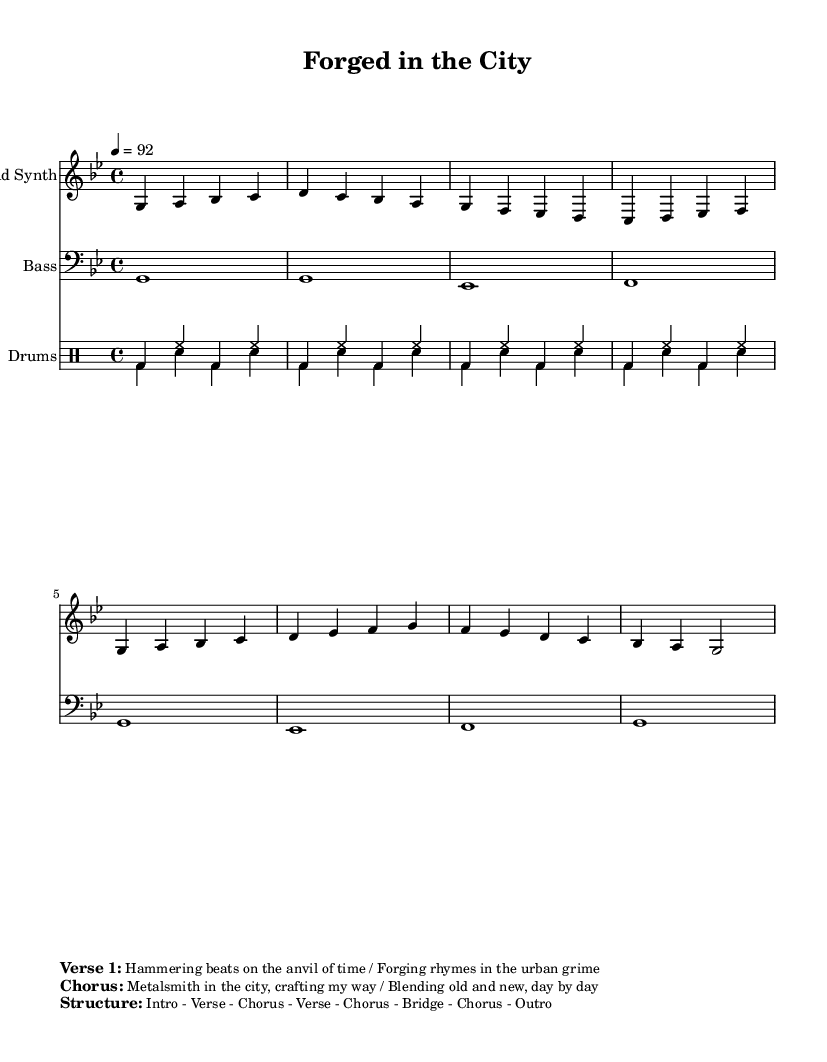What is the key signature of this music? The key signature is indicated as G minor, which has two flats (B and E) in its key signature. This is confirmed by looking at the staff where the flats are placed.
Answer: G minor What is the time signature of this piece? The time signature shown at the beginning of the sheet music is 4/4, which means there are four beats in a measure and the quarter note gets one beat. This can be seen in the timing notation right after the key signature.
Answer: 4/4 What is the tempo marking for the music? The tempo is marked as 4 = 92, meaning there should be 92 quarter note beats per minute in this piece. The tempo marking is right below the time signature, indicating how fast the music should be played.
Answer: 92 What instrument plays the lead part? The lead part is designated for the "Lead Synth", as stated in the instrument name next to that staff. This is a clear label at the beginning of the staff, identifying which instrument performs that line.
Answer: Lead Synth How many sections does the music have? The structure of the music is detailed in the markup, stating that it follows the order of Intro - Verse - Chorus - Verse - Chorus - Bridge - Chorus - Outro. By counting the sections listed, we can see there are seven distinct parts.
Answer: Seven What kind of rhythm does the drum part primarily use? The drum part primarily uses a steady beat pattern as shown in the drummode, where the bass drum alternates with the hi-hat, giving it a consistent hip-hop rhythm. This can be deduced from the repeated four-bar patterns throughout the piece.
Answer: Steady beat What does the chorus express about the theme? The chorus expresses the theme of blending traditional craftsmanship with modern urban culture. This is evident from the lyrics provided in the markup, highlighting the metalsmith's journey and creative process in the city.
Answer: Crafting my way 